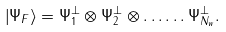<formula> <loc_0><loc_0><loc_500><loc_500>\left | \Psi _ { F } \right \rangle = \Psi _ { 1 } ^ { \perp } \otimes \Psi _ { 2 } ^ { \perp } \otimes \dots \dots \Psi _ { N _ { w } } ^ { \perp } .</formula> 